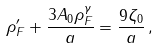<formula> <loc_0><loc_0><loc_500><loc_500>\rho ^ { \prime } _ { F } + \frac { 3 A _ { 0 } \rho _ { F } ^ { \gamma } } { a } = \frac { 9 \zeta _ { 0 } } { a } \, ,</formula> 